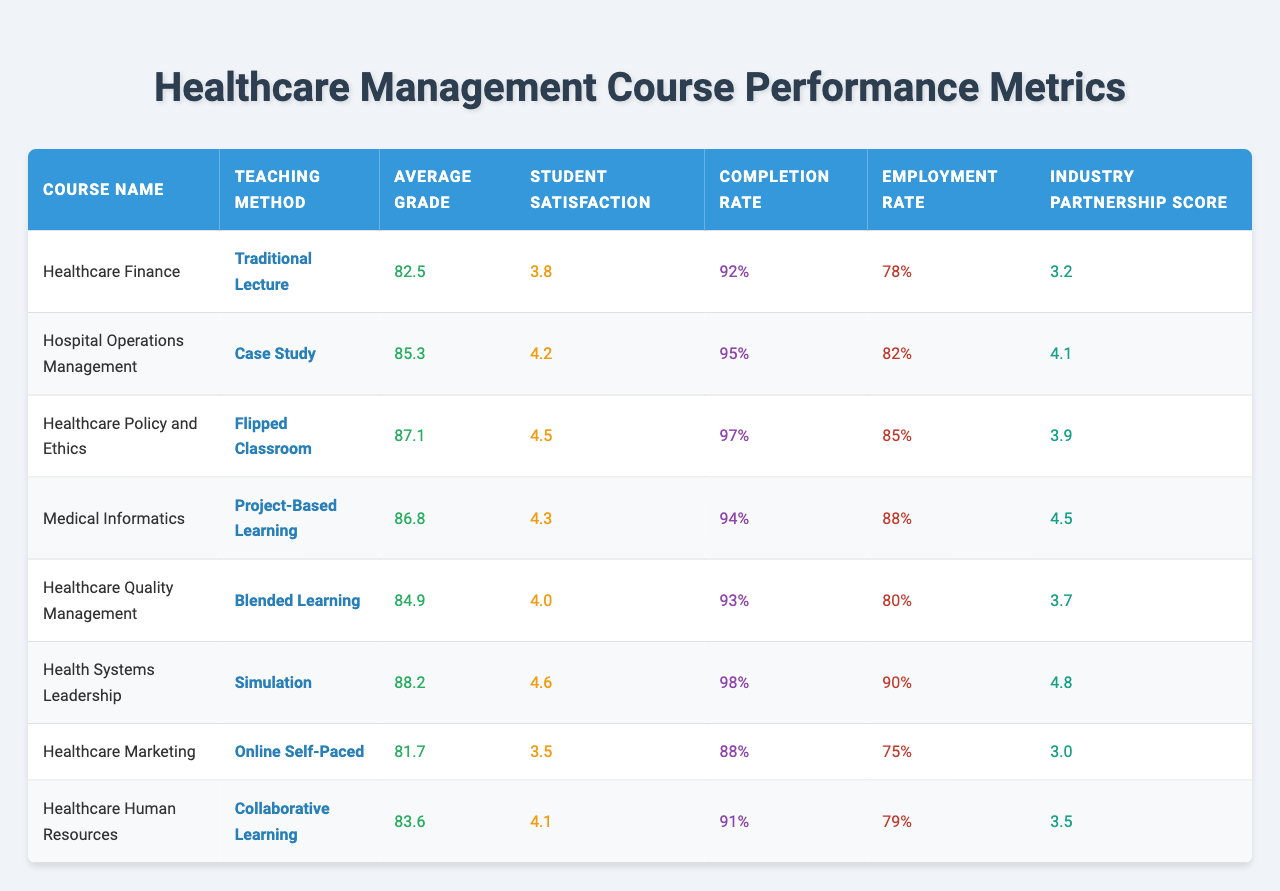What is the average grade for the course "Healthcare Finance"? The table shows the average grade for each course. For "Healthcare Finance," the average grade listed is 82.5.
Answer: 82.5 What is the student satisfaction score for "Medical Informatics"? Referring to the table, the student satisfaction score for "Medical Informatics" is 4.3.
Answer: 4.3 Which course has the highest employment rate? Looking at the employment rates, "Health Systems Leadership" has the highest employment rate of 90%.
Answer: 90% How does the average grade of "Healthcare Quality Management" compare to "Healthcare Finance"? "Healthcare Quality Management" has an average grade of 84.9, while "Healthcare Finance" has 82.5. The difference is 84.9 - 82.5 = 2.4, so "Healthcare Quality Management" is higher by 2.4 points.
Answer: 2.4 What is the average student satisfaction score across all courses? To find the average student satisfaction score, sum the scores: (3.8 + 4.2 + 4.5 + 4.3 + 4.0 + 4.6 + 3.5 + 4.1) = 33.0. There are 8 courses, so the average is 33.0 / 8 = 4.125.
Answer: 4.125 Is the completion rate for "Healthcare Marketing" above 90%? The completion rate for "Healthcare Marketing" is 88%, which is below 90%. Therefore, the answer is no.
Answer: No Which teaching method corresponds to the highest industry partnership score? The highest industry partnership score is 4.8, which corresponds to the teaching method "Simulation" used in the course "Health Systems Leadership."
Answer: Simulation What is the difference in completion rate between "Flipped Classroom" and "Traditional Lecture"? The completion rate for "Flipped Classroom" is 97%, while for "Traditional Lecture," it is 92%. The difference is 97 - 92 = 5%.
Answer: 5% Is the average grade for "Healthcare Human Resources" higher or lower than 85? The average grade for "Healthcare Human Resources" is 83.6, which is lower than 85. Therefore, the answer is lower.
Answer: Lower Which course has the lowest student satisfaction score, and what is that score? The lowest student satisfaction score is 3.5 for the course "Healthcare Marketing."
Answer: 3.5 What is the total employment rate for all courses listed in the table? To calculate the total employment rate, sum the employment rates: (78 + 82 + 85 + 88 + 80 + 90 + 75 + 79) = 667.
Answer: 667 